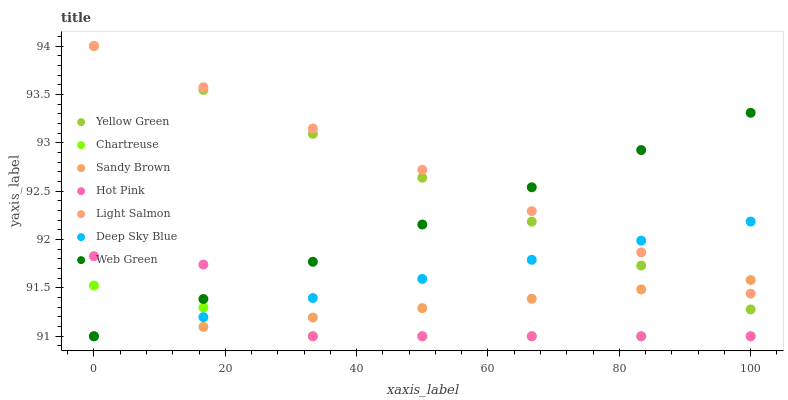Does Chartreuse have the minimum area under the curve?
Answer yes or no. Yes. Does Light Salmon have the maximum area under the curve?
Answer yes or no. Yes. Does Yellow Green have the minimum area under the curve?
Answer yes or no. No. Does Yellow Green have the maximum area under the curve?
Answer yes or no. No. Is Light Salmon the smoothest?
Answer yes or no. Yes. Is Hot Pink the roughest?
Answer yes or no. Yes. Is Yellow Green the smoothest?
Answer yes or no. No. Is Yellow Green the roughest?
Answer yes or no. No. Does Hot Pink have the lowest value?
Answer yes or no. Yes. Does Yellow Green have the lowest value?
Answer yes or no. No. Does Yellow Green have the highest value?
Answer yes or no. Yes. Does Hot Pink have the highest value?
Answer yes or no. No. Is Chartreuse less than Light Salmon?
Answer yes or no. Yes. Is Yellow Green greater than Hot Pink?
Answer yes or no. Yes. Does Web Green intersect Yellow Green?
Answer yes or no. Yes. Is Web Green less than Yellow Green?
Answer yes or no. No. Is Web Green greater than Yellow Green?
Answer yes or no. No. Does Chartreuse intersect Light Salmon?
Answer yes or no. No. 